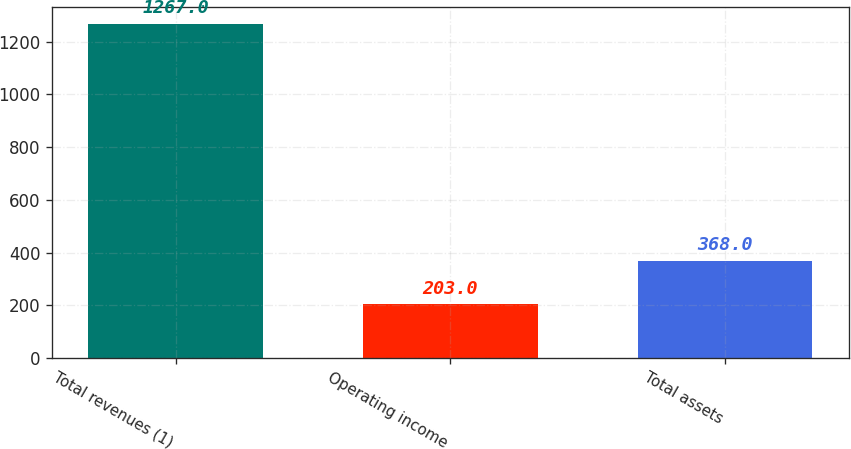<chart> <loc_0><loc_0><loc_500><loc_500><bar_chart><fcel>Total revenues (1)<fcel>Operating income<fcel>Total assets<nl><fcel>1267<fcel>203<fcel>368<nl></chart> 